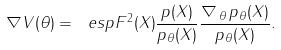<formula> <loc_0><loc_0><loc_500><loc_500>\nabla V ( \theta ) = \ e s p { F ^ { 2 } ( X ) \frac { p ( X ) } { p _ { \theta } ( X ) } \frac { \nabla _ { \, \theta } \, p _ { \theta } ( X ) } { p _ { \theta } ( X ) } } .</formula> 